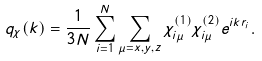Convert formula to latex. <formula><loc_0><loc_0><loc_500><loc_500>q _ { \chi } ( k ) = \frac { 1 } { 3 N } \sum _ { i = 1 } ^ { N } \sum _ { \mu = x , y , z } \chi _ { i \mu } ^ { ( 1 ) } \chi _ { i \mu } ^ { ( 2 ) } e ^ { i k r _ { i } } .</formula> 